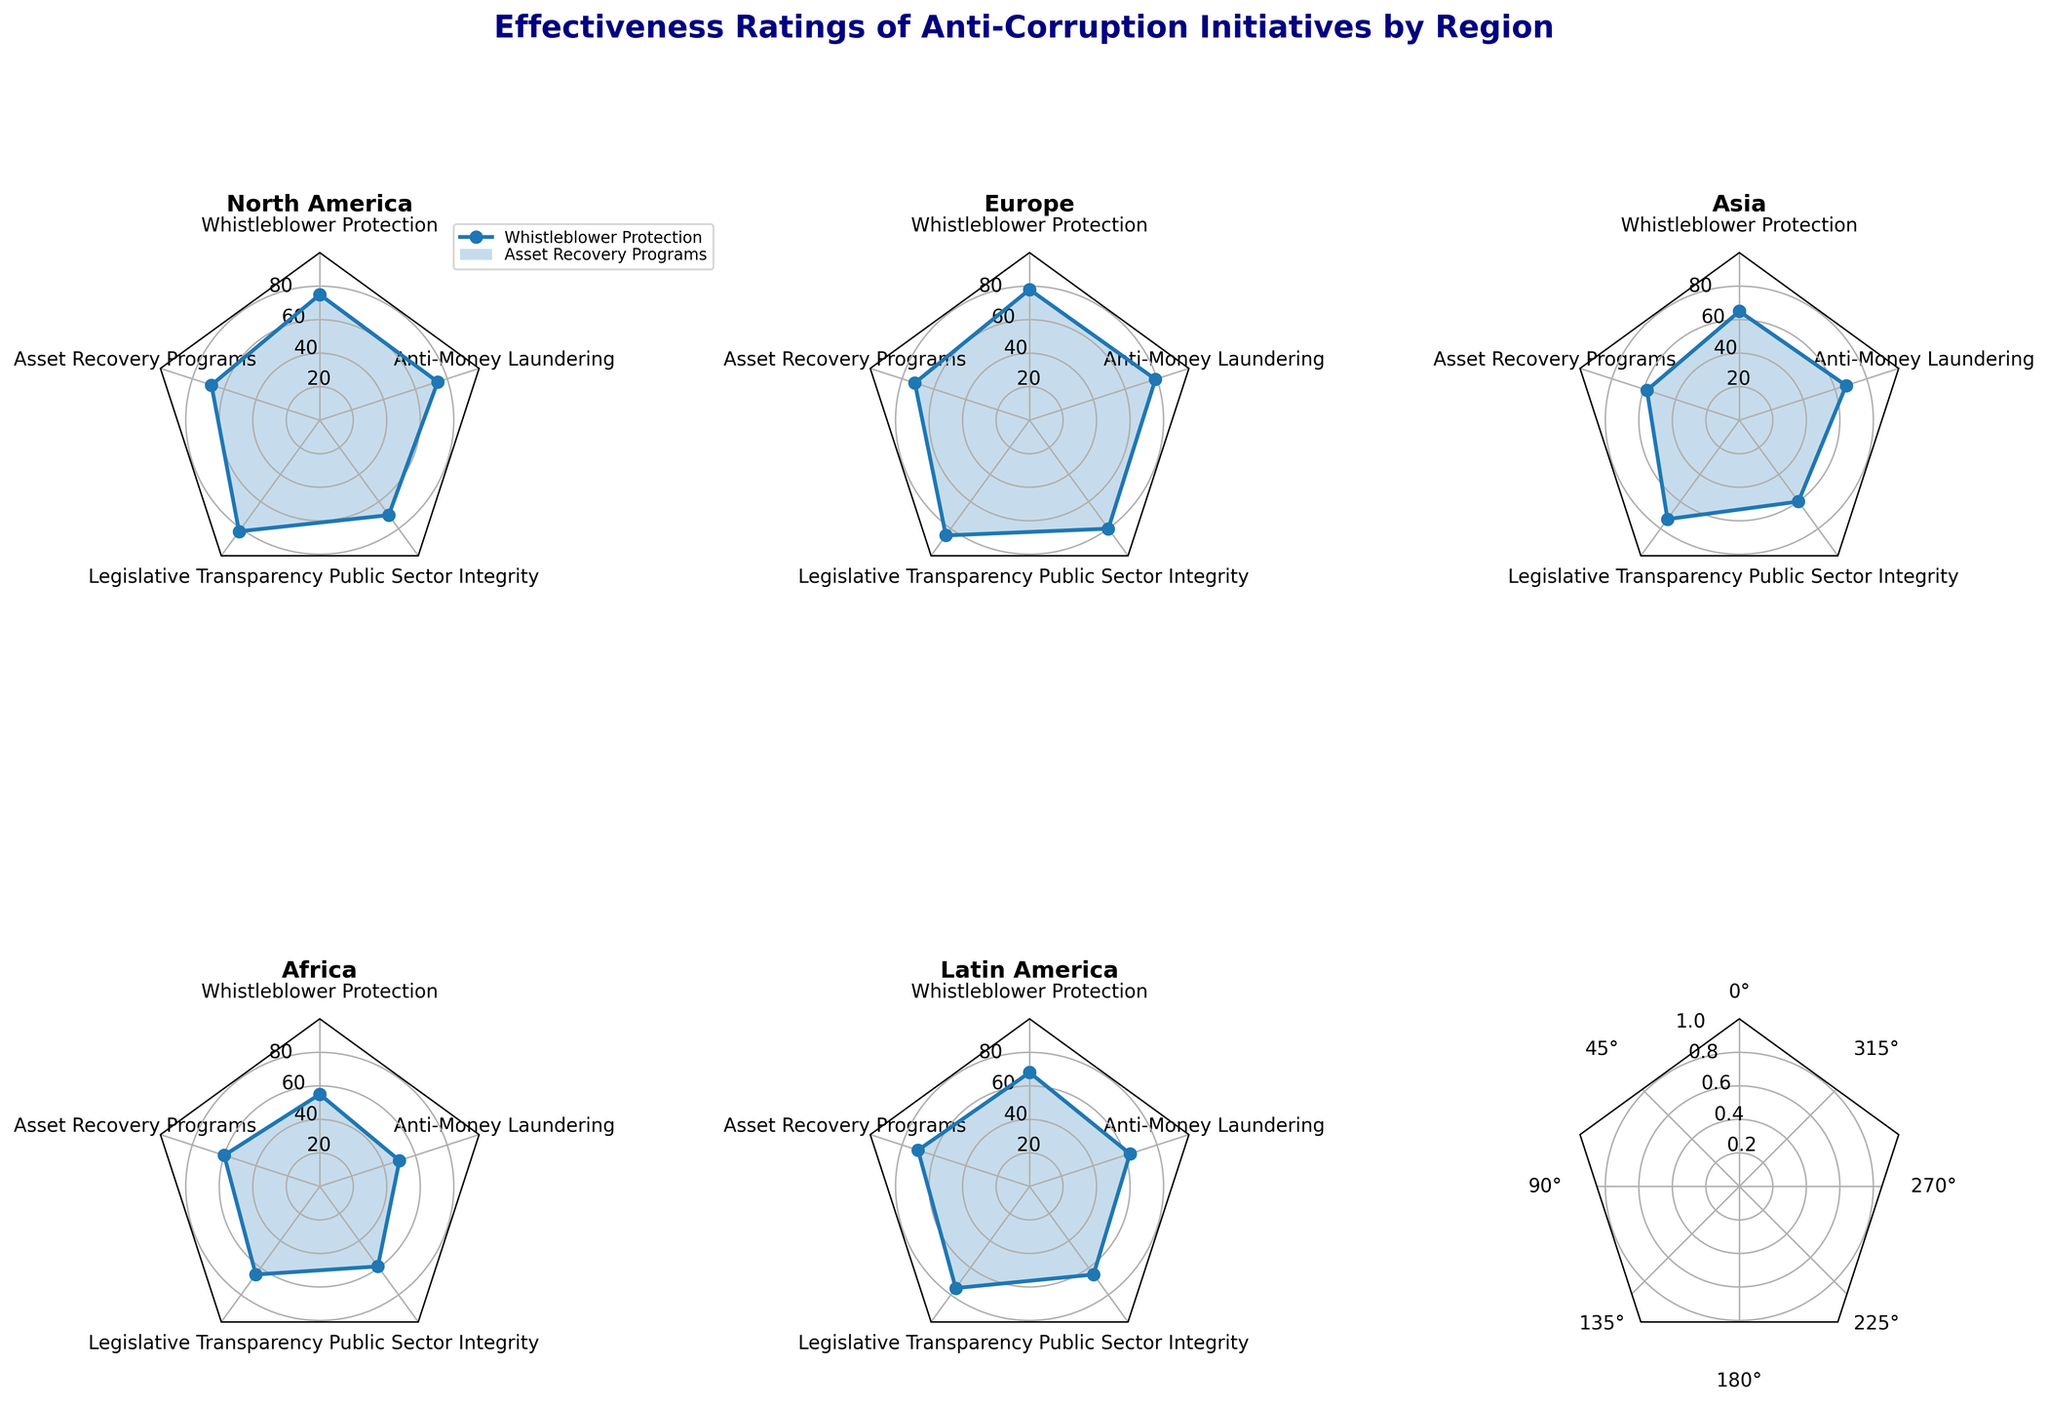What's the title of the chart? The title is usually located at the top of the chart, and it summarizes the main point or purpose of the figure. In this chart, the title is given at the top center, indicating the subject matter it addresses.
Answer: Effectiveness Ratings of Anti-Corruption Initiatives by Region What are the five anti-corruption initiatives listed in the chart? By observing the radar chart, you can identify the various axes that represent different anti-corruption initiatives. Each axis is labeled with one of the initiatives to provide context for the ratings.
Answer: Whistleblower Protection, Asset Recovery Programs, Legislative Transparency, Public Sector Integrity, Anti-Money Laundering Which region has the highest effectiveness rating for Legislative Transparency? To determine the highest rating for Legislative Transparency, compare the points on the corresponding axis for all regions. The region whose point is farthest from the center has the highest rating.
Answer: Europe In which region is the effectiveness of Anti-Money Laundering initiatives the lowest? Look at the Anti-Money Laundering axis for all regions and identify the point closest to the center. This point represents the lowest effectiveness rating.
Answer: Africa Compare the effectiveness of Whistleblower Protection between North America and Africa. Locate the Whistleblower Protection axis and compare the distance of the points for North America and Africa from the center. The point farther from the center represents a higher effectiveness rating.
Answer: North America is higher What's the average effectiveness rating of all initiatives in Latin America? Add up the effectiveness ratings for all initiatives in Latin America and then divide by the number of initiatives to find the average. The ratings are Whistleblower Protection (68), Asset Recovery Programs (70), Legislative Transparency (75), Public Sector Integrity (65), Anti-Money Laundering (63). The sum is 341, and the average is 341/5 = 68.2.
Answer: 68.2 Which initiative in Asia has the highest effectiveness rating? Locate the data points for Asia and compare their distances from the center for each initiative. The point farthest from the center represents the highest effectiveness rating.
Answer: Legislative Transparency What is the difference in effectiveness rating for Public Sector Integrity between Europe and Asia? Locate the Public Sector Integrity axis and note the ratings for Europe (80) and Asia (60). Subtract the lower rating from the higher rating to find the difference. 80 - 60 = 20.
Answer: 20 Across all regions, which initiative consistently shows the highest effectiveness rating? Compare the effectiveness ratings for each initiative across all regions and identify which initiative has the highest ratings on average. Legislative Transparency consistently has high ratings across all regions, notably in Europe (85).
Answer: Legislative Transparency 